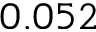Convert formula to latex. <formula><loc_0><loc_0><loc_500><loc_500>0 . 0 5 2</formula> 